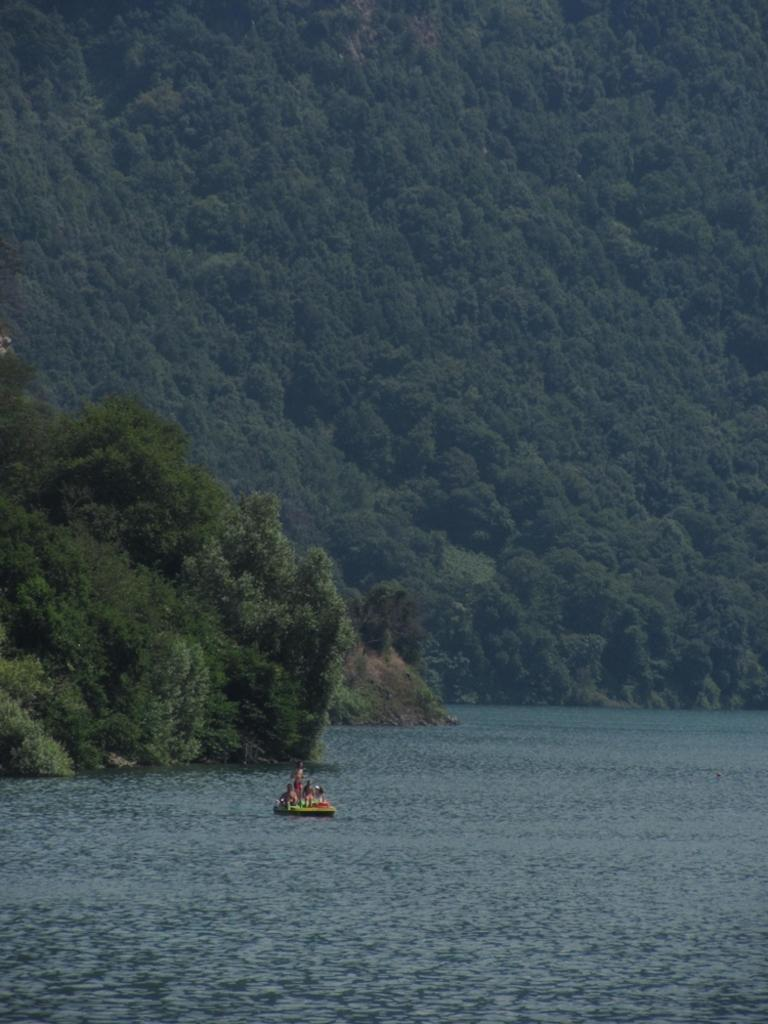What activity are the persons in the image engaged in? The persons in the image are boating. Where are the persons boating? They are on the surface of a river. What can be seen in the background of the image? There is a mountain in the background of the image. How is the mountain covered? The mountain is covered with trees. How many cows are lying on the beds in the image? There are no cows or beds present in the image. 